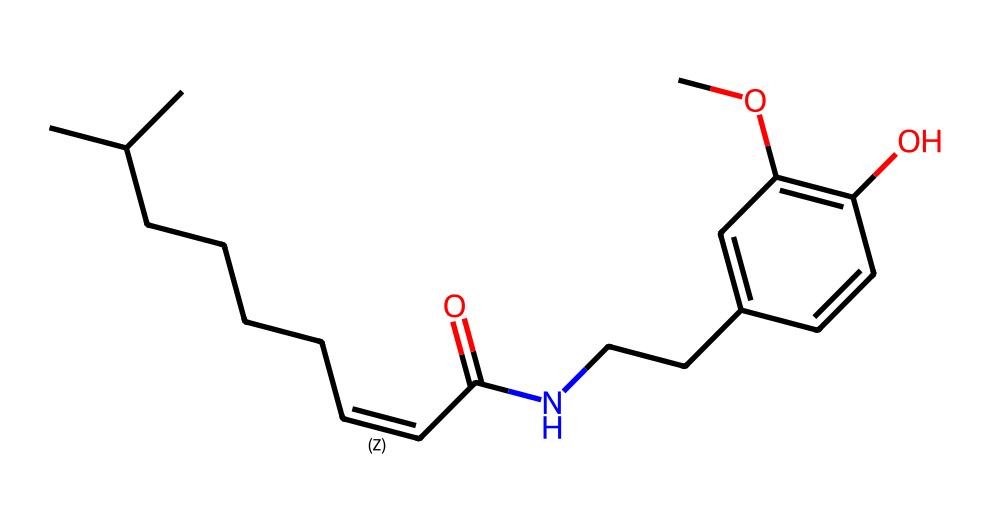What is the primary functional group present in capsaicin? The structure of capsaicin includes an amide group (–C(=O)N–) where a carbonyl (C=O) is connected to a nitrogen atom. This amide functional group is prominent in the molecular structure.
Answer: amide How many carbon atoms are in capsaicin? Reviewing the SMILES representation, we can identify each carbon atom by counting all the 'C' symbols, including those in branches and rings. In total, there are 18 carbon atoms present in the structure.
Answer: 18 What type of compound is capsaicin classified as? Capsaicin is contained within the alkaloid category of compounds, characterized by the presence of nitrogen and derived from plant sources. The presence of the nitrogen atom supports this classification.
Answer: alkaloid Does capsaicin contain an aromatic ring? Examining the structure, we can see a six-membered carbon ring with alternating double bonds, which is characteristic of aromatic compounds. This ring structure directly indicates the presence of aromaticity within capsaicin.
Answer: yes What is the number of double bonds in the capsaicin structure? By reviewing the carbon-carbon and carbon-oxygen bonds connected through double connections in the SMILES notation, we can systematically count them. In total, capsaicin contains 3 double bonds.
Answer: 3 What role does the hydroxyl group play in the structure of capsaicin? The hydroxyl group (–OH) contributes to the chemical's solubility in water and enhances its interaction with biological targets. This functionality is crucial for the spicy sensation it generates in mammals.
Answer: solubility How does the presence of nitrogen in capsaicin affect its pharmacological properties? Nitrogen contributes to the overall polarity of capsaicin, enabling it to interact effectively with specific receptors in the body, such as TRPV1. This interaction is significant for its spicy and analgesic effects.
Answer: polarity 